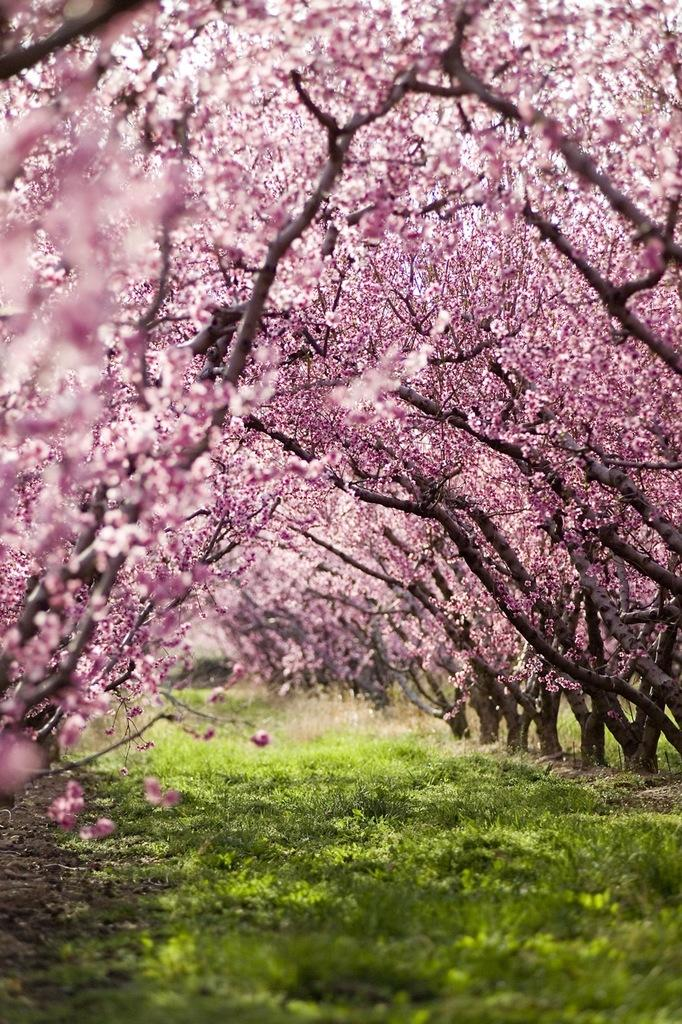What type of vegetation is in the middle of the image? There is grass in the middle of the image. What other natural elements can be seen in the image? There are trees in the image. What is the color of the trees? The trees are in purple color. How many fingers can be seen holding the trees in the image? There are no fingers or hands holding the trees in the image; the trees are standing on their own. 